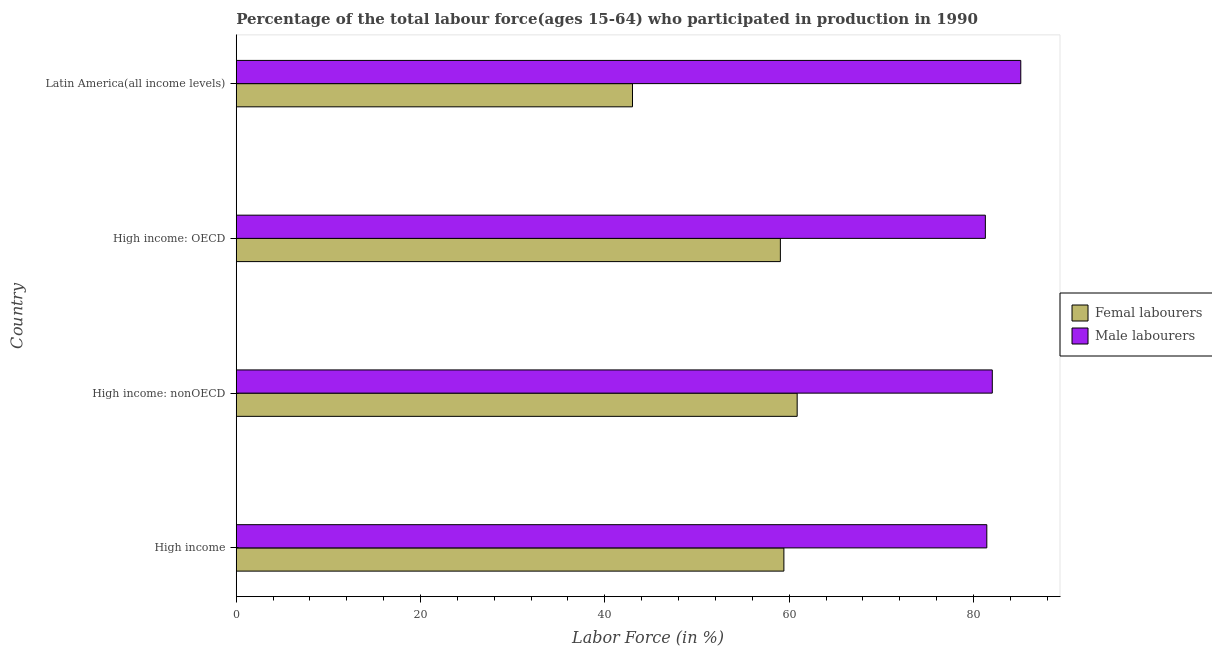How many different coloured bars are there?
Your response must be concise. 2. How many groups of bars are there?
Ensure brevity in your answer.  4. Are the number of bars per tick equal to the number of legend labels?
Offer a terse response. Yes. Are the number of bars on each tick of the Y-axis equal?
Offer a very short reply. Yes. How many bars are there on the 4th tick from the top?
Offer a very short reply. 2. What is the label of the 1st group of bars from the top?
Your response must be concise. Latin America(all income levels). What is the percentage of male labour force in High income?
Your response must be concise. 81.45. Across all countries, what is the maximum percentage of female labor force?
Give a very brief answer. 60.87. Across all countries, what is the minimum percentage of female labor force?
Your response must be concise. 43. In which country was the percentage of male labour force maximum?
Your answer should be compact. Latin America(all income levels). In which country was the percentage of female labor force minimum?
Your answer should be compact. Latin America(all income levels). What is the total percentage of female labor force in the graph?
Offer a terse response. 222.35. What is the difference between the percentage of male labour force in High income and that in High income: OECD?
Provide a short and direct response. 0.16. What is the difference between the percentage of male labour force in High income: nonOECD and the percentage of female labor force in Latin America(all income levels)?
Provide a succinct answer. 39.05. What is the average percentage of female labor force per country?
Make the answer very short. 55.59. What is the difference between the percentage of female labor force and percentage of male labour force in High income?
Provide a succinct answer. -22.02. In how many countries, is the percentage of male labour force greater than 84 %?
Ensure brevity in your answer.  1. What is the ratio of the percentage of male labour force in High income to that in High income: OECD?
Provide a short and direct response. 1. Is the difference between the percentage of male labour force in High income and Latin America(all income levels) greater than the difference between the percentage of female labor force in High income and Latin America(all income levels)?
Make the answer very short. No. What is the difference between the highest and the second highest percentage of female labor force?
Offer a terse response. 1.44. What is the difference between the highest and the lowest percentage of male labour force?
Offer a terse response. 3.84. In how many countries, is the percentage of female labor force greater than the average percentage of female labor force taken over all countries?
Offer a very short reply. 3. What does the 1st bar from the top in High income: nonOECD represents?
Ensure brevity in your answer.  Male labourers. What does the 2nd bar from the bottom in Latin America(all income levels) represents?
Ensure brevity in your answer.  Male labourers. How many bars are there?
Your answer should be very brief. 8. How many countries are there in the graph?
Your answer should be compact. 4. Does the graph contain any zero values?
Your response must be concise. No. Does the graph contain grids?
Your answer should be very brief. No. How are the legend labels stacked?
Provide a short and direct response. Vertical. What is the title of the graph?
Your answer should be compact. Percentage of the total labour force(ages 15-64) who participated in production in 1990. What is the label or title of the Y-axis?
Make the answer very short. Country. What is the Labor Force (in %) of Femal labourers in High income?
Make the answer very short. 59.43. What is the Labor Force (in %) of Male labourers in High income?
Ensure brevity in your answer.  81.45. What is the Labor Force (in %) in Femal labourers in High income: nonOECD?
Offer a very short reply. 60.87. What is the Labor Force (in %) of Male labourers in High income: nonOECD?
Offer a very short reply. 82.05. What is the Labor Force (in %) in Femal labourers in High income: OECD?
Offer a very short reply. 59.05. What is the Labor Force (in %) in Male labourers in High income: OECD?
Keep it short and to the point. 81.29. What is the Labor Force (in %) in Femal labourers in Latin America(all income levels)?
Your answer should be very brief. 43. What is the Labor Force (in %) of Male labourers in Latin America(all income levels)?
Ensure brevity in your answer.  85.14. Across all countries, what is the maximum Labor Force (in %) of Femal labourers?
Give a very brief answer. 60.87. Across all countries, what is the maximum Labor Force (in %) in Male labourers?
Your response must be concise. 85.14. Across all countries, what is the minimum Labor Force (in %) of Femal labourers?
Provide a short and direct response. 43. Across all countries, what is the minimum Labor Force (in %) in Male labourers?
Offer a terse response. 81.29. What is the total Labor Force (in %) of Femal labourers in the graph?
Your response must be concise. 222.35. What is the total Labor Force (in %) of Male labourers in the graph?
Offer a terse response. 329.93. What is the difference between the Labor Force (in %) of Femal labourers in High income and that in High income: nonOECD?
Make the answer very short. -1.44. What is the difference between the Labor Force (in %) of Male labourers in High income and that in High income: nonOECD?
Your answer should be compact. -0.6. What is the difference between the Labor Force (in %) of Femal labourers in High income and that in High income: OECD?
Make the answer very short. 0.38. What is the difference between the Labor Force (in %) of Male labourers in High income and that in High income: OECD?
Offer a terse response. 0.16. What is the difference between the Labor Force (in %) in Femal labourers in High income and that in Latin America(all income levels)?
Your response must be concise. 16.43. What is the difference between the Labor Force (in %) in Male labourers in High income and that in Latin America(all income levels)?
Provide a short and direct response. -3.69. What is the difference between the Labor Force (in %) of Femal labourers in High income: nonOECD and that in High income: OECD?
Your answer should be very brief. 1.82. What is the difference between the Labor Force (in %) of Male labourers in High income: nonOECD and that in High income: OECD?
Provide a succinct answer. 0.75. What is the difference between the Labor Force (in %) in Femal labourers in High income: nonOECD and that in Latin America(all income levels)?
Provide a succinct answer. 17.87. What is the difference between the Labor Force (in %) in Male labourers in High income: nonOECD and that in Latin America(all income levels)?
Provide a succinct answer. -3.09. What is the difference between the Labor Force (in %) of Femal labourers in High income: OECD and that in Latin America(all income levels)?
Give a very brief answer. 16.05. What is the difference between the Labor Force (in %) of Male labourers in High income: OECD and that in Latin America(all income levels)?
Keep it short and to the point. -3.84. What is the difference between the Labor Force (in %) of Femal labourers in High income and the Labor Force (in %) of Male labourers in High income: nonOECD?
Make the answer very short. -22.62. What is the difference between the Labor Force (in %) in Femal labourers in High income and the Labor Force (in %) in Male labourers in High income: OECD?
Offer a very short reply. -21.86. What is the difference between the Labor Force (in %) of Femal labourers in High income and the Labor Force (in %) of Male labourers in Latin America(all income levels)?
Make the answer very short. -25.71. What is the difference between the Labor Force (in %) in Femal labourers in High income: nonOECD and the Labor Force (in %) in Male labourers in High income: OECD?
Provide a short and direct response. -20.42. What is the difference between the Labor Force (in %) of Femal labourers in High income: nonOECD and the Labor Force (in %) of Male labourers in Latin America(all income levels)?
Offer a very short reply. -24.27. What is the difference between the Labor Force (in %) in Femal labourers in High income: OECD and the Labor Force (in %) in Male labourers in Latin America(all income levels)?
Give a very brief answer. -26.09. What is the average Labor Force (in %) in Femal labourers per country?
Give a very brief answer. 55.59. What is the average Labor Force (in %) of Male labourers per country?
Keep it short and to the point. 82.48. What is the difference between the Labor Force (in %) in Femal labourers and Labor Force (in %) in Male labourers in High income?
Offer a terse response. -22.02. What is the difference between the Labor Force (in %) in Femal labourers and Labor Force (in %) in Male labourers in High income: nonOECD?
Offer a very short reply. -21.17. What is the difference between the Labor Force (in %) in Femal labourers and Labor Force (in %) in Male labourers in High income: OECD?
Offer a very short reply. -22.25. What is the difference between the Labor Force (in %) in Femal labourers and Labor Force (in %) in Male labourers in Latin America(all income levels)?
Keep it short and to the point. -42.14. What is the ratio of the Labor Force (in %) of Femal labourers in High income to that in High income: nonOECD?
Your response must be concise. 0.98. What is the ratio of the Labor Force (in %) in Male labourers in High income to that in High income: OECD?
Provide a succinct answer. 1. What is the ratio of the Labor Force (in %) of Femal labourers in High income to that in Latin America(all income levels)?
Provide a short and direct response. 1.38. What is the ratio of the Labor Force (in %) in Male labourers in High income to that in Latin America(all income levels)?
Ensure brevity in your answer.  0.96. What is the ratio of the Labor Force (in %) in Femal labourers in High income: nonOECD to that in High income: OECD?
Your answer should be very brief. 1.03. What is the ratio of the Labor Force (in %) in Male labourers in High income: nonOECD to that in High income: OECD?
Keep it short and to the point. 1.01. What is the ratio of the Labor Force (in %) in Femal labourers in High income: nonOECD to that in Latin America(all income levels)?
Offer a terse response. 1.42. What is the ratio of the Labor Force (in %) in Male labourers in High income: nonOECD to that in Latin America(all income levels)?
Provide a succinct answer. 0.96. What is the ratio of the Labor Force (in %) of Femal labourers in High income: OECD to that in Latin America(all income levels)?
Ensure brevity in your answer.  1.37. What is the ratio of the Labor Force (in %) in Male labourers in High income: OECD to that in Latin America(all income levels)?
Make the answer very short. 0.95. What is the difference between the highest and the second highest Labor Force (in %) in Femal labourers?
Your answer should be compact. 1.44. What is the difference between the highest and the second highest Labor Force (in %) in Male labourers?
Your answer should be very brief. 3.09. What is the difference between the highest and the lowest Labor Force (in %) in Femal labourers?
Keep it short and to the point. 17.87. What is the difference between the highest and the lowest Labor Force (in %) in Male labourers?
Make the answer very short. 3.84. 